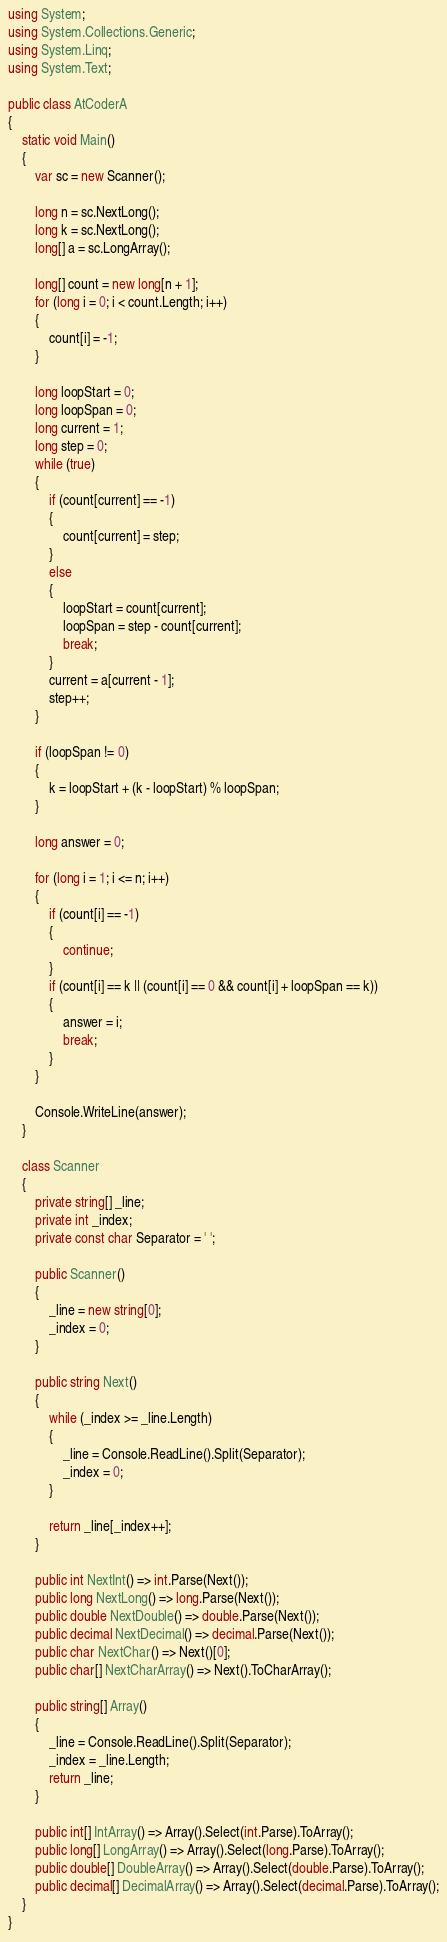Convert code to text. <code><loc_0><loc_0><loc_500><loc_500><_C#_>using System;
using System.Collections.Generic;
using System.Linq;
using System.Text;

public class AtCoderA
{
    static void Main()
    {
        var sc = new Scanner();

        long n = sc.NextLong();
        long k = sc.NextLong();
        long[] a = sc.LongArray();

        long[] count = new long[n + 1];
        for (long i = 0; i < count.Length; i++)
        {
            count[i] = -1;
        }

        long loopStart = 0;
        long loopSpan = 0;
        long current = 1;
        long step = 0;
        while (true)
        {
            if (count[current] == -1)
            {
                count[current] = step;
            }
            else
            {
                loopStart = count[current];
                loopSpan = step - count[current];
                break;
            }
            current = a[current - 1];
            step++;
        }

        if (loopSpan != 0)
        {
            k = loopStart + (k - loopStart) % loopSpan;
        }

        long answer = 0;

        for (long i = 1; i <= n; i++)
        {
            if (count[i] == -1)
            {
                continue;
            }
            if (count[i] == k || (count[i] == 0 && count[i] + loopSpan == k))
            {
                answer = i;
                break;
            }
        }

        Console.WriteLine(answer);
    }

    class Scanner
    {
        private string[] _line;
        private int _index;
        private const char Separator = ' ';

        public Scanner()
        {
            _line = new string[0];
            _index = 0;
        }

        public string Next()
        {
            while (_index >= _line.Length)
            {
                _line = Console.ReadLine().Split(Separator);
                _index = 0;
            }

            return _line[_index++];
        }

        public int NextInt() => int.Parse(Next());
        public long NextLong() => long.Parse(Next());
        public double NextDouble() => double.Parse(Next());
        public decimal NextDecimal() => decimal.Parse(Next());
        public char NextChar() => Next()[0];
        public char[] NextCharArray() => Next().ToCharArray();

        public string[] Array()
        {
            _line = Console.ReadLine().Split(Separator);
            _index = _line.Length;
            return _line;
        }

        public int[] IntArray() => Array().Select(int.Parse).ToArray();
        public long[] LongArray() => Array().Select(long.Parse).ToArray();
        public double[] DoubleArray() => Array().Select(double.Parse).ToArray();
        public decimal[] DecimalArray() => Array().Select(decimal.Parse).ToArray();
    }
}</code> 